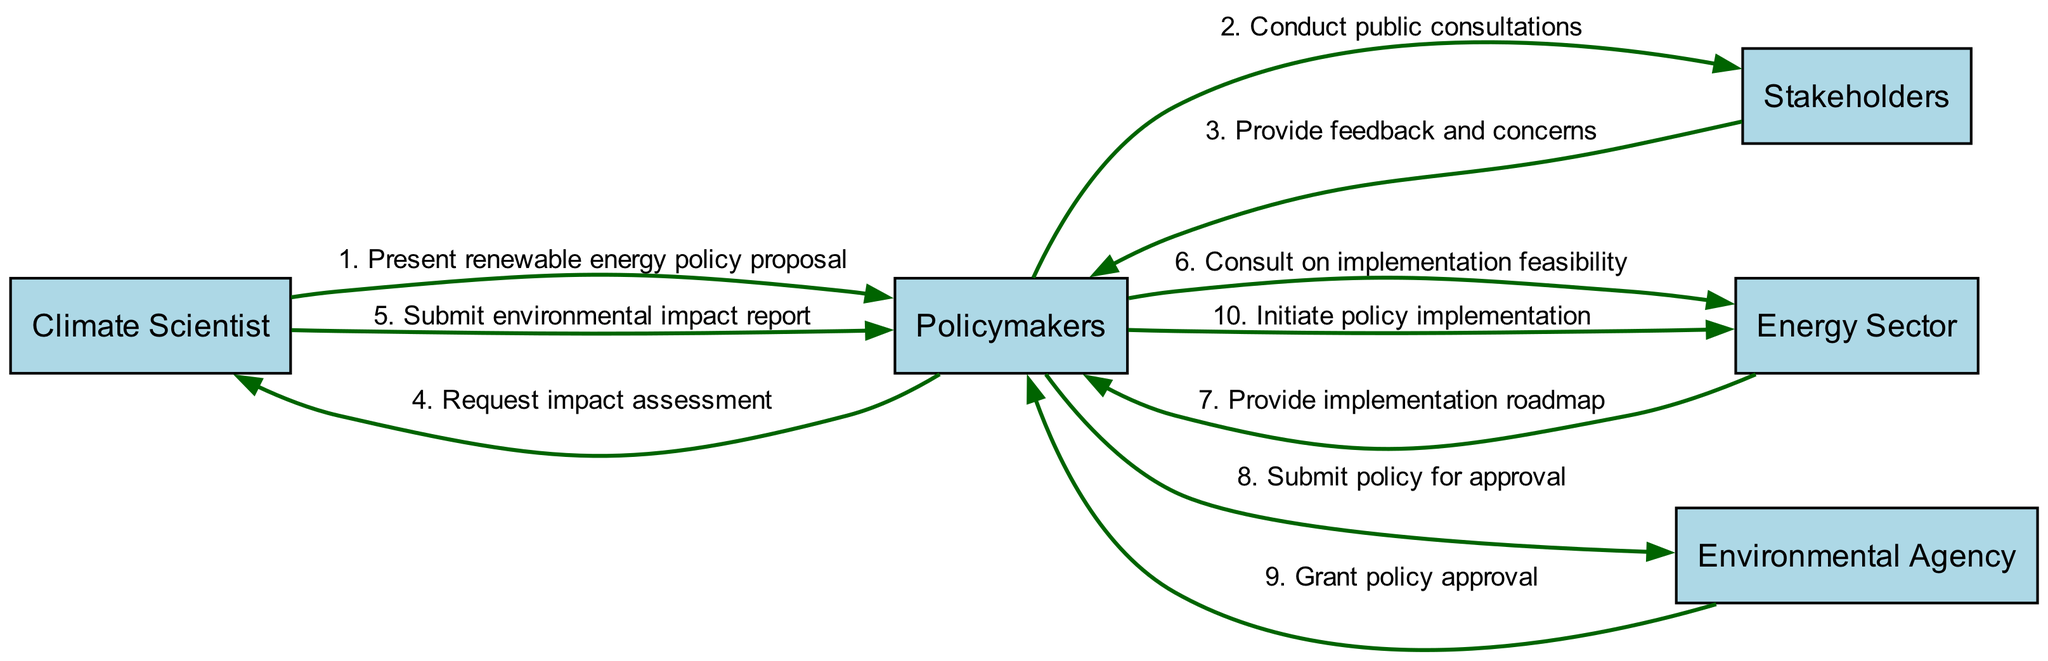What is the first action in the sequence? The first action in the sequence is initiated by the Climate Scientist, who presents the renewable energy policy proposal to the Policymakers. This is directly indicated as the first step in the diagram.
Answer: Present renewable energy policy proposal How many actors are involved in the policy lifecycle? There are five actors involved in the policy lifecycle. They are the Climate Scientist, Policymakers, Stakeholders, Energy Sector, and Environmental Agency. This can be counted directly from the list of actors in the diagram.
Answer: Five What does the Policymakers do after receiving feedback from Stakeholders? After receiving feedback and concerns from the Stakeholders, Policymakers request an impact assessment from the Climate Scientist. This action is the next step highlighted in the sequence right after the feedback.
Answer: Request impact assessment Who provides the implementation roadmap? The Energy Sector provides the implementation roadmap to the Policymakers after they consult on implementation feasibility. This is shown in the sequence as a direct interaction step.
Answer: Energy Sector How many messages are sent from Policymakers to other actors? Policymakers send a total of four messages to other actors throughout the sequence: conducting public consultations, requesting impact assessments, consulting on implementation feasibility, and submitting the policy for approval. This is derived by counting each individual message sent by Policymakers in the sequence.
Answer: Four What is the final step before policy implementation? The final step before policy implementation is the grant of policy approval by the Environmental Agency to the Policymakers. This is indicated in the sequence as the last interaction prior to initiating implementation.
Answer: Grant policy approval Which actor initiates the policy implementation? The Policymakers initiate the policy implementation after receiving approval from the Environmental Agency. This step is clearly outlined as the action taken by Policymakers in the sequence.
Answer: Policymakers What type of consultation is conducted before feedback? The type of consultation conducted before feedback is public consultations by the Policymakers with Stakeholders. This is explicitly mentioned in the sequence and sets the stage for the subsequent feedback.
Answer: Public consultations 